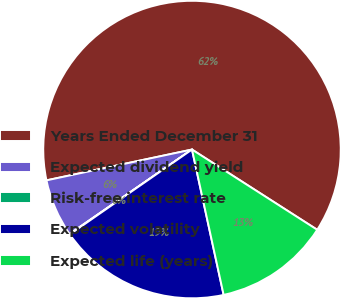Convert chart. <chart><loc_0><loc_0><loc_500><loc_500><pie_chart><fcel>Years Ended December 31<fcel>Expected dividend yield<fcel>Risk-free interest rate<fcel>Expected volatility<fcel>Expected life (years)<nl><fcel>62.39%<fcel>6.29%<fcel>0.05%<fcel>18.75%<fcel>12.52%<nl></chart> 